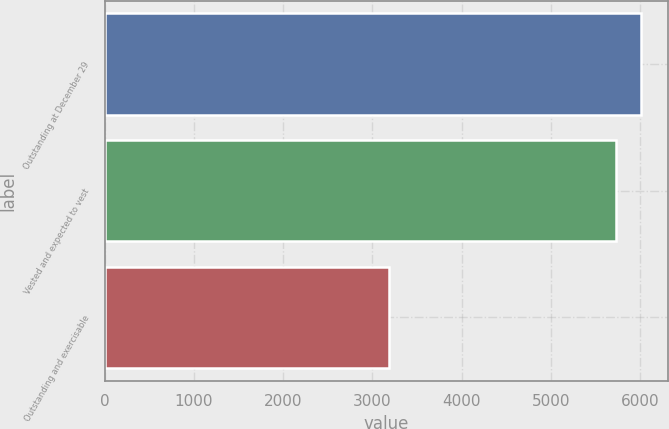Convert chart. <chart><loc_0><loc_0><loc_500><loc_500><bar_chart><fcel>Outstanding at December 29<fcel>Vested and expected to vest<fcel>Outstanding and exercisable<nl><fcel>6007.7<fcel>5732<fcel>3182<nl></chart> 